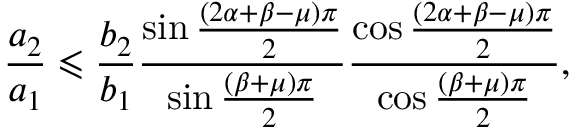<formula> <loc_0><loc_0><loc_500><loc_500>\frac { a _ { 2 } } { a _ { 1 } } \leqslant \frac { b _ { 2 } } { b _ { 1 } } \frac { \sin \frac { \left ( 2 \alpha + \beta - \mu \right ) \pi } { 2 } } { \sin \frac { \left ( \beta + \mu \right ) \pi } { 2 } } \frac { \cos \frac { \left ( 2 \alpha + \beta - \mu \right ) \pi } { 2 } } { \cos \frac { \left ( \beta + \mu \right ) \pi } { 2 } } ,</formula> 